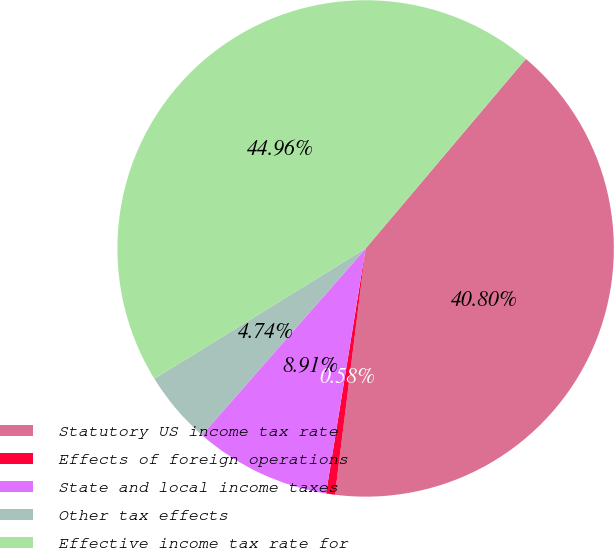<chart> <loc_0><loc_0><loc_500><loc_500><pie_chart><fcel>Statutory US income tax rate<fcel>Effects of foreign operations<fcel>State and local income taxes<fcel>Other tax effects<fcel>Effective income tax rate for<nl><fcel>40.8%<fcel>0.58%<fcel>8.91%<fcel>4.74%<fcel>44.96%<nl></chart> 